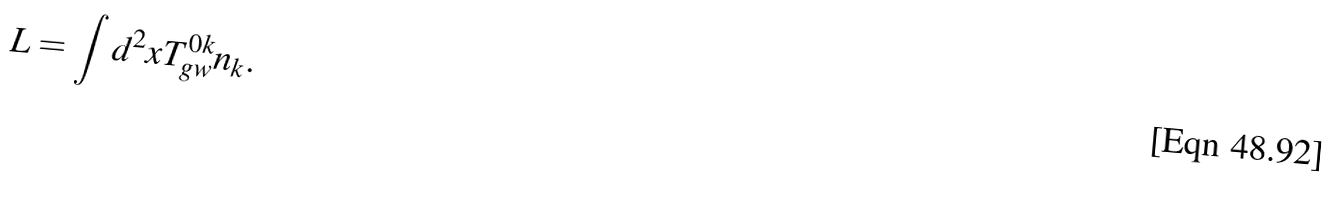<formula> <loc_0><loc_0><loc_500><loc_500>L = \int d ^ { 2 } x T _ { g w } ^ { 0 k } n _ { k } .</formula> 